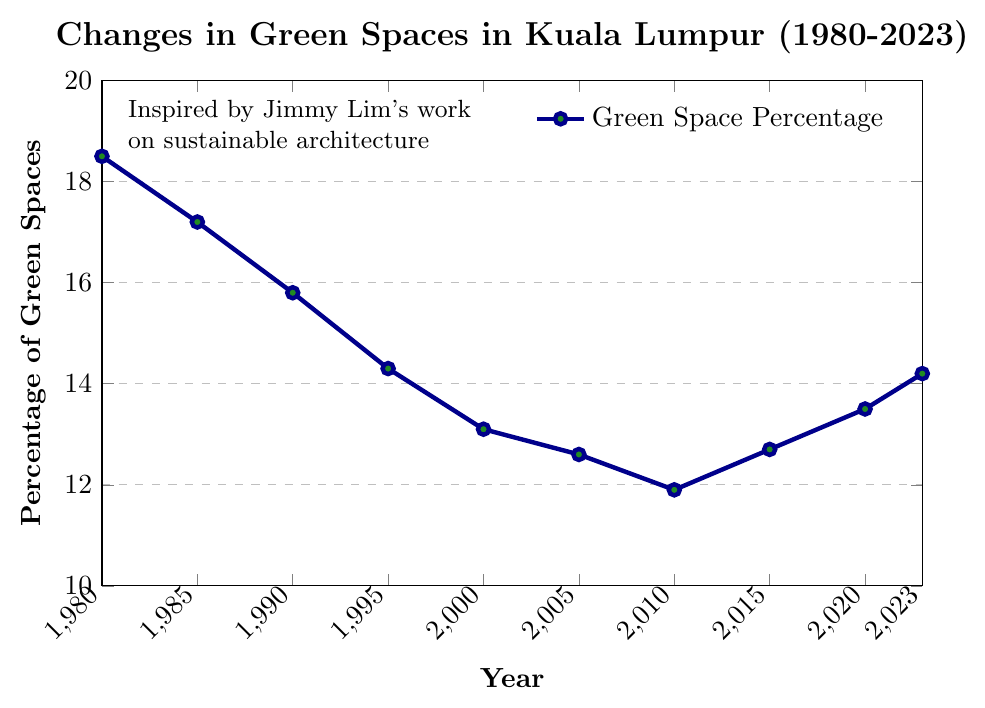what's the overall trend in the percentage of green spaces from 1980 to 2023? Observing the line chart, we can see that the percentage of green spaces consistently decreases from 1980 to 2010, before starting to increase again from 2015 to 2023.
Answer: Initially decreased, then increased Which year has the lowest percentage of green spaces? From the figure, the year with the lowest data point is 2010, showing the lowest percentage of green spaces.
Answer: 2010 How much did the percentage of green spaces change from 1980 to 2010? In 1980, the percentage was 18.5%, and in 2010, it was 11.9%. The change is calculated as 18.5% - 11.9%.
Answer: 6.6% Between which consecutive years did the percentage of green spaces increase the most? Looking at the data points, the largest increase occurs between 2010 and 2015, where the percentage changes from 11.9% to 12.7%. The increase is 12.7% - 11.9%.
Answer: 2010 to 2015 What is the average percentage of green spaces over the years provided? To find the average, sum all the percentages and divide by the number of years (10): (18.5 + 17.2 + 15.8 + 14.3 + 13.1 + 12.6 + 11.9 + 12.7 + 13.5 + 14.2) / 10. The sum is 144.8. Therefore, the average is 144.8 / 10.
Answer: 14.48% During which decade did the percentage of green spaces drop the most? Calculating changes in each decade:
1980-1990: 18.5 - 15.8 = 2.7%
1990-2000: 15.8 - 13.1 = 2.7%
2000-2010: 13.1 - 11.9 = 1.2%
The largest drop is 2.7%, which occurs in both 1980-1990 and 1990-2000.
Answer: 1980-1990 and 1990-2000 What is the difference between the highest and lowest percentage of green spaces? The highest is 18.5% in 1980, and the lowest is 11.9% in 2010. The difference is 18.5% - 11.9%.
Answer: 6.6% By how much did the percentage of green spaces increase from 2010 to 2023? In 2010, the percentage was 11.9%. By 2023, it was 14.2%. The increase is calculated as 14.2% - 11.9%.
Answer: 2.3% What significant trend do you notice from 2010 to 2023? After a long period of decline, the percentage of green spaces started to increase from 2010 onwards. This reversal of trend suggests a positive change or intervention in urban planning.
Answer: Increasing trend from 2010 to 2023 Which years had a percentage of green spaces equal to or greater than 15%? From the figure, only the years 1980 (18.5%), 1985 (17.2%), and 1990 (15.8%) had percentages equal to or greater than 15%.
Answer: 1980, 1985, 1990 